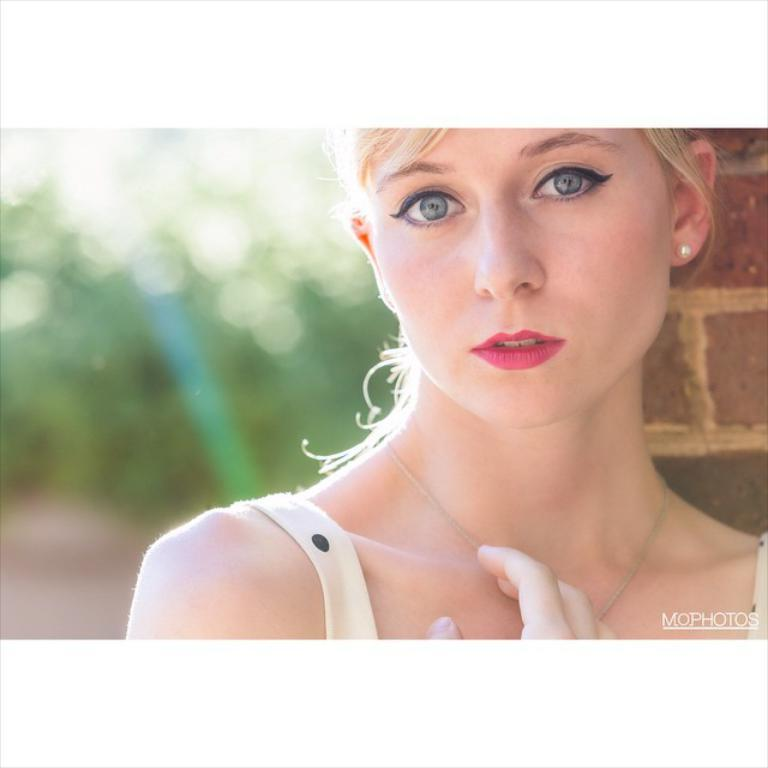Who is the main subject in the image? There is a woman in the image. What is the woman wearing? The woman is wearing a dress, a necklace, and earrings. What can be seen in the background of the image? There is a wall in the background of the image, and it appears blurry. Is there any additional information about the image itself? Yes, there is a watermark on the image. What type of thread is being used to measure the woman's height in the image? There is no thread or measurement of height in the image; it simply features a woman wearing a dress, necklace, and earrings with a blurry wall in the background and a watermark. 